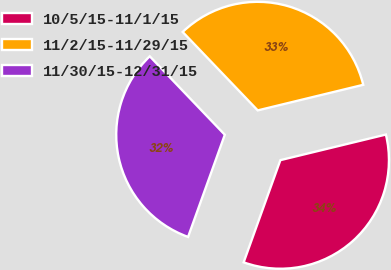<chart> <loc_0><loc_0><loc_500><loc_500><pie_chart><fcel>10/5/15-11/1/15<fcel>11/2/15-11/29/15<fcel>11/30/15-12/31/15<nl><fcel>34.28%<fcel>33.36%<fcel>32.36%<nl></chart> 